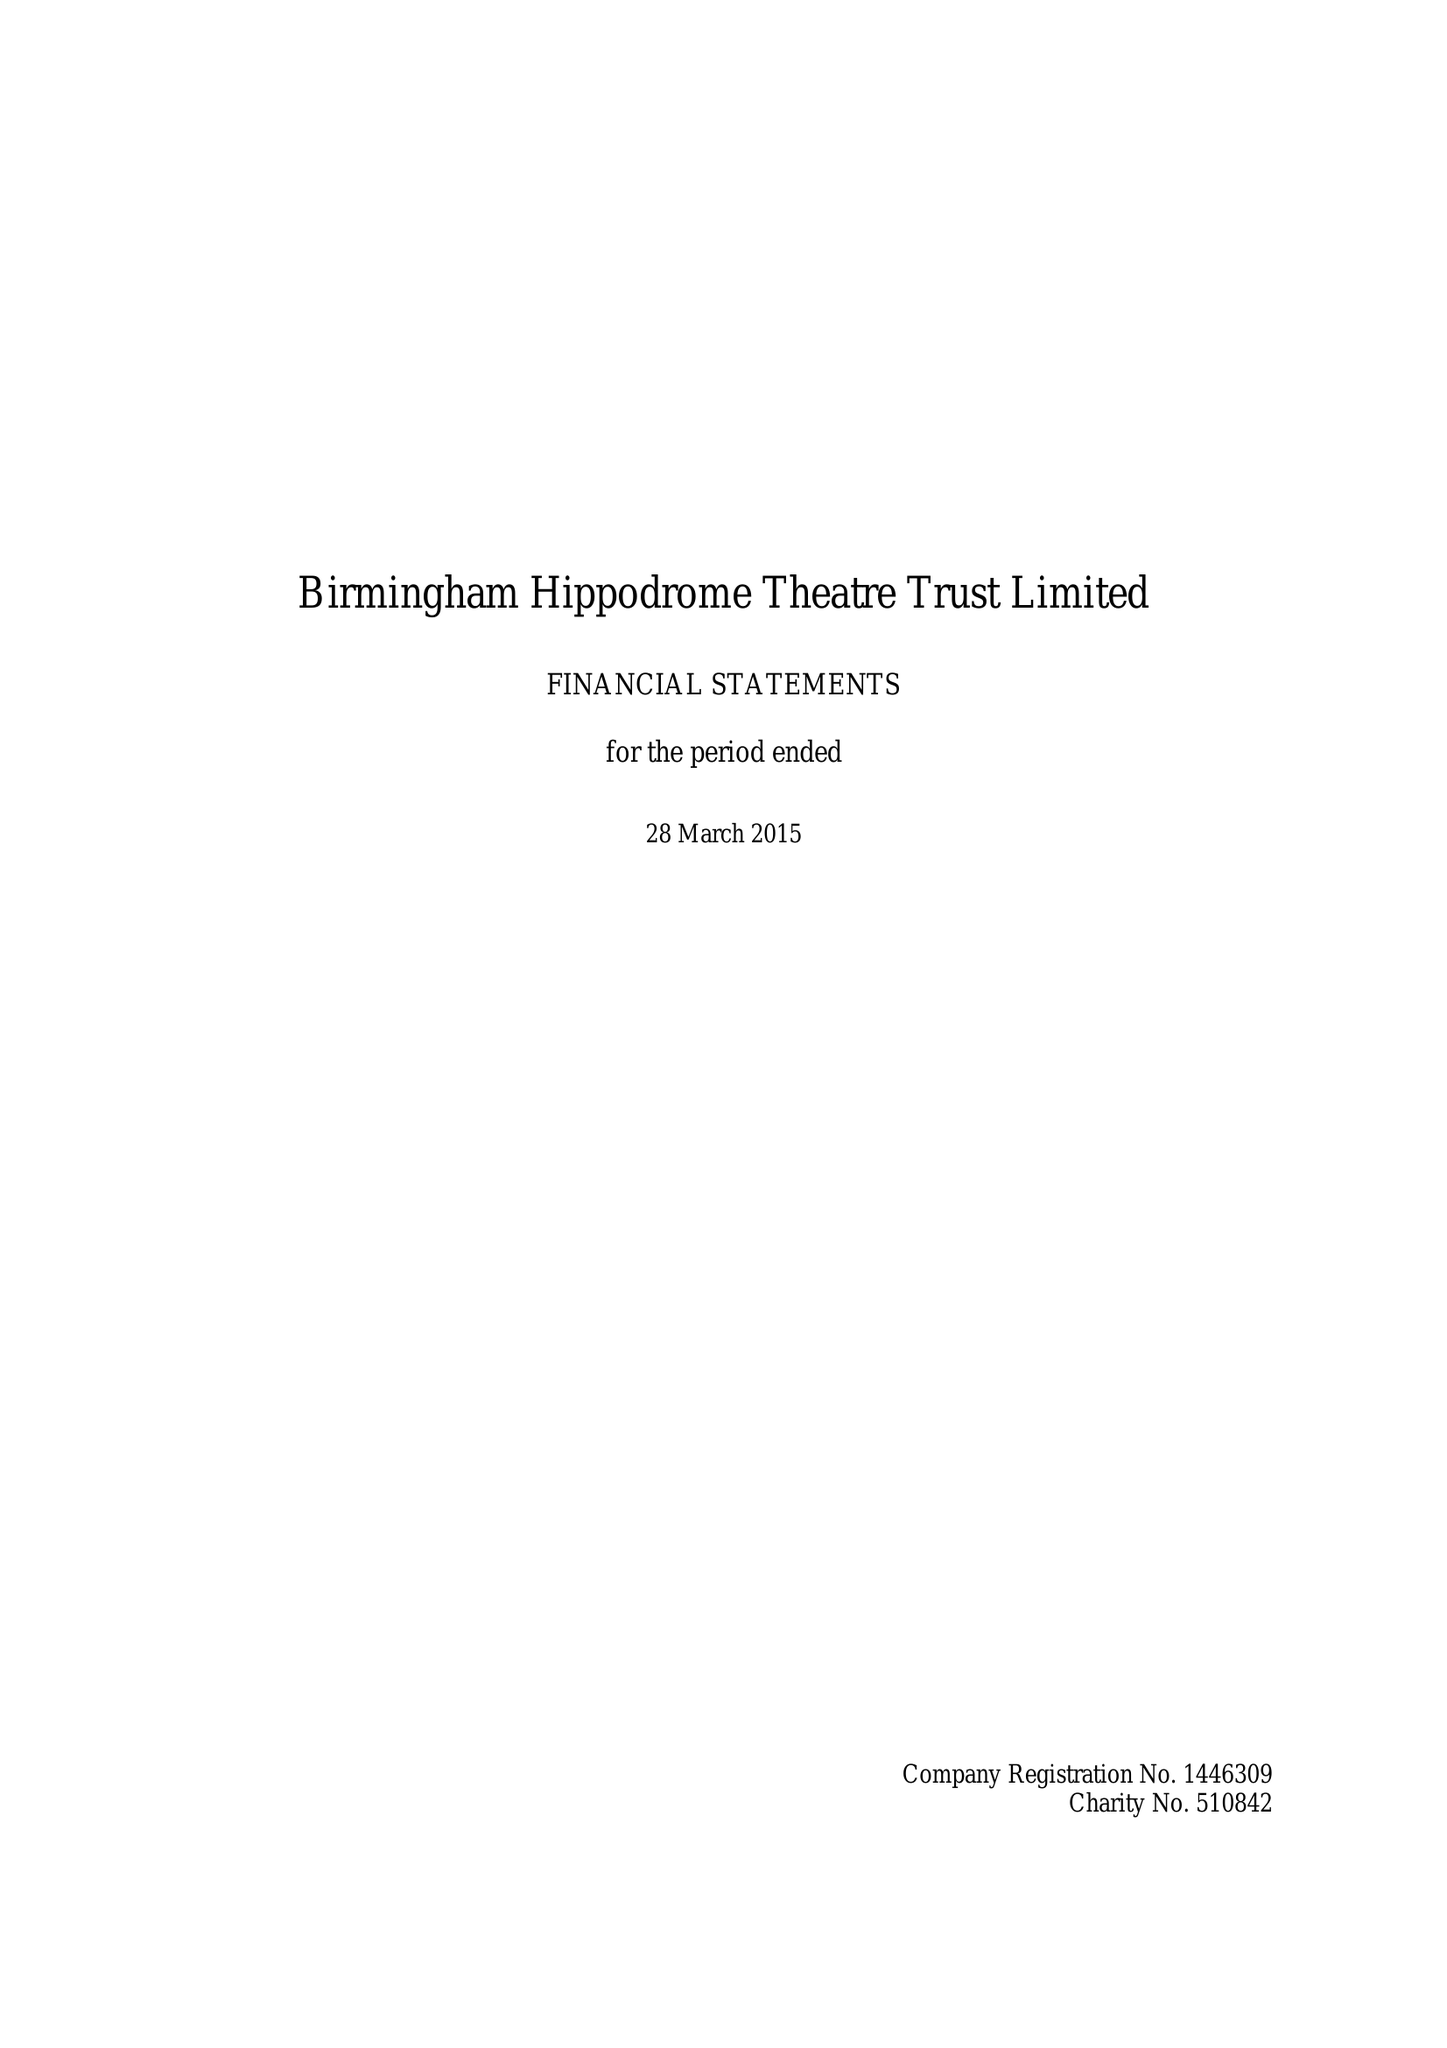What is the value for the charity_name?
Answer the question using a single word or phrase. Birmingham Hippodrome Theatre Trust Ltd. 